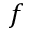<formula> <loc_0><loc_0><loc_500><loc_500>f</formula> 